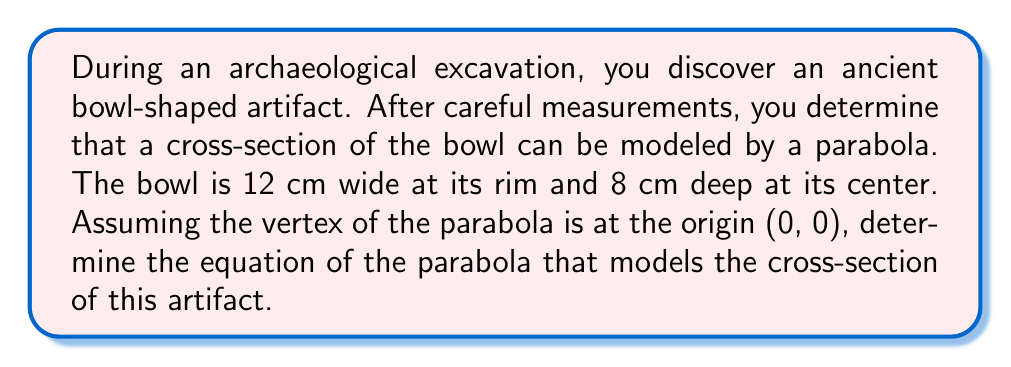Teach me how to tackle this problem. Let's approach this step-by-step:

1) The general equation of a parabola with vertex at the origin is:
   $$ y = ax^2 $$
   where $a$ is a constant we need to determine.

2) We know two points on this parabola:
   - The vertex: (0, 0)
   - The rim: (6, 8) or (-6, 8), since the bowl is 12 cm wide and 8 cm deep

3) We can use either of these rim points to find $a$. Let's use (6, 8):
   $$ 8 = a(6)^2 $$

4) Simplify:
   $$ 8 = 36a $$

5) Solve for $a$:
   $$ a = \frac{8}{36} = \frac{2}{9} \approx 0.222 $$

6) Therefore, the equation of the parabola is:
   $$ y = \frac{2}{9}x^2 $$

7) To verify, we can check the other rim point (-6, 8):
   $$ 8 = \frac{2}{9}(-6)^2 = \frac{2}{9}(36) = 8 $$
   This confirms our equation is correct.
Answer: $$ y = \frac{2}{9}x^2 $$ 